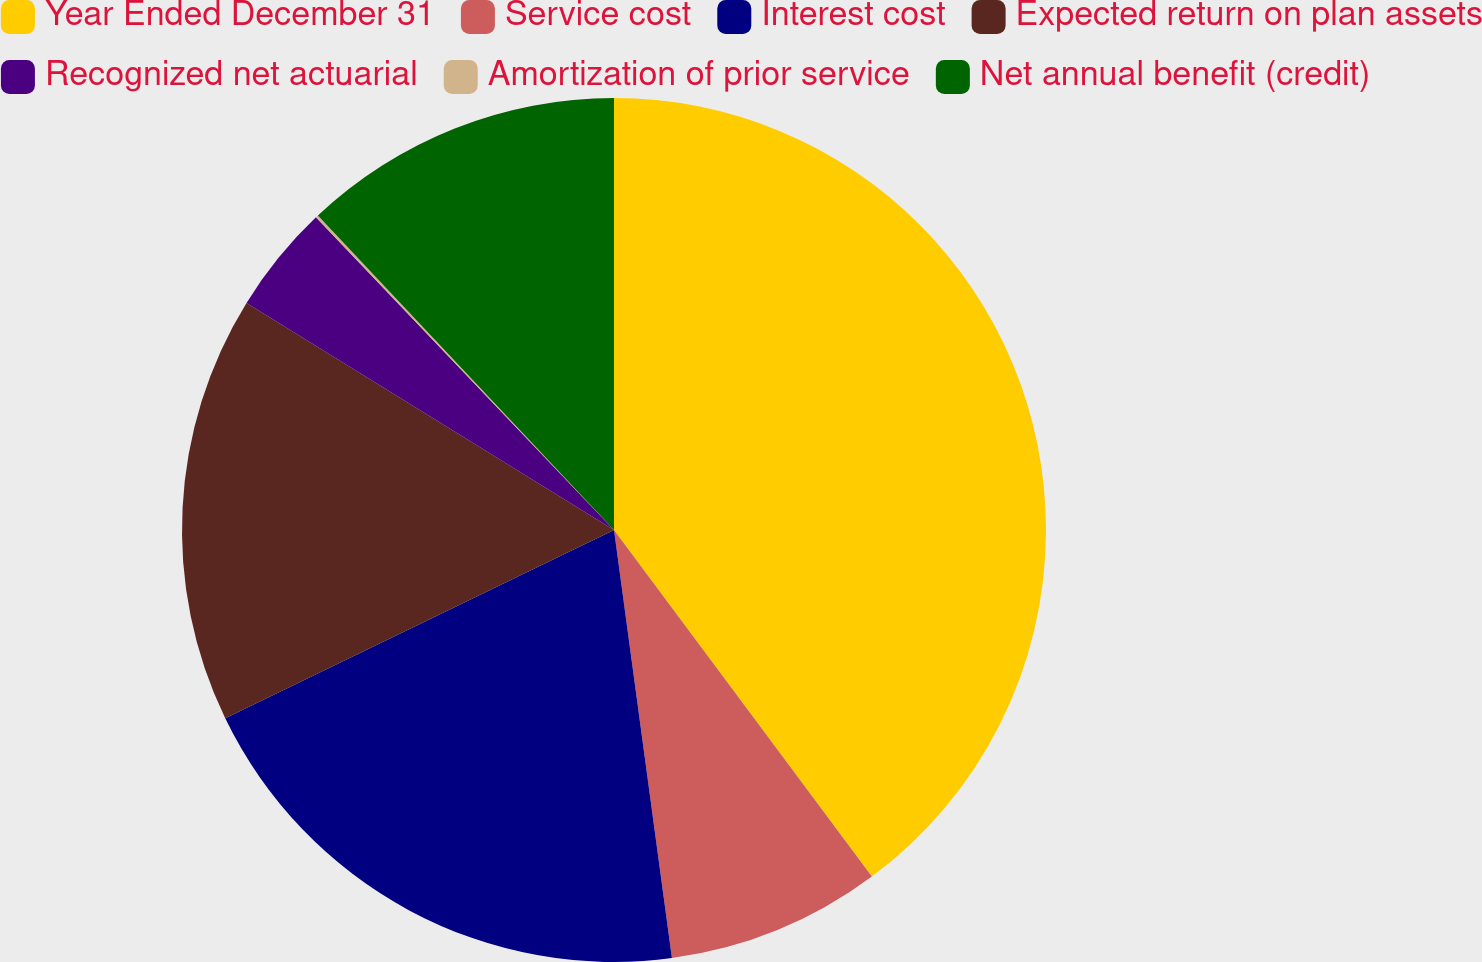Convert chart. <chart><loc_0><loc_0><loc_500><loc_500><pie_chart><fcel>Year Ended December 31<fcel>Service cost<fcel>Interest cost<fcel>Expected return on plan assets<fcel>Recognized net actuarial<fcel>Amortization of prior service<fcel>Net annual benefit (credit)<nl><fcel>39.82%<fcel>8.04%<fcel>19.96%<fcel>15.99%<fcel>4.07%<fcel>0.1%<fcel>12.02%<nl></chart> 